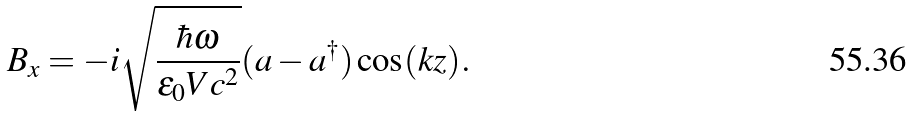<formula> <loc_0><loc_0><loc_500><loc_500>B _ { x } = - i \sqrt { \frac { \hbar { \omega } } { \varepsilon _ { 0 } V c ^ { 2 } } } ( a - a ^ { \dagger } ) \cos ( k z ) .</formula> 